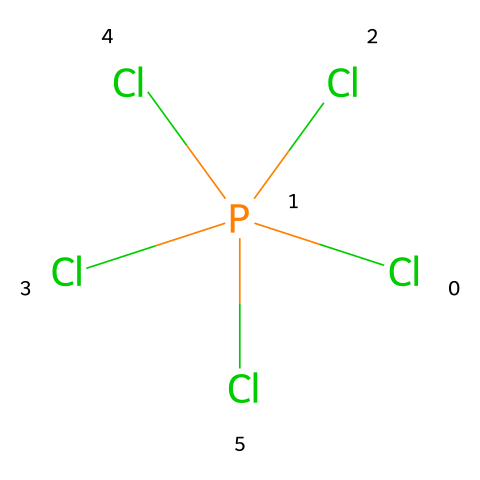How many chlorine atoms are present in the structure? The structure shows the chemical formula Cl[P](Cl)(Cl)(Cl)Cl, indicating five chlorine atoms bonded to the phosphorus atom.
Answer: five What is the central atom in this molecule? In the structure, phosphorus (P) is the main atom around which the chlorines are attached, making it the central atom in the molecule.
Answer: phosphorus Is phosphorus pentachloride polar or nonpolar? The presence of chlorine atoms surrounding the phosphorus may suggest a shape with asymmetrical charge distribution, but due to its symmetrical arrangement, phosphorus pentachloride is considered nonpolar.
Answer: nonpolar What is the hybridization of the phosphorus atom? Given that phosphorus is surrounded by five chlorine atoms and has five bonding pairs, the hybridization is sp3d, which corresponds to a trigonal bipyramidal geometry.
Answer: sp3d How many bonding pairs does phosphorus have in this structure? The structure Cl[P](Cl)(Cl)(Cl)Cl indicates that phosphorus has five pairs of bonded electrons, one for each chlorine atom attached.
Answer: five What type of compound is phosphorus pentachloride classified as? Phosphorus pentachloride is classified as a hypervalent compound because it has more than four bonds derived from the central atom, phosphorus, which exceeds the octet rule.
Answer: hypervalent compound 